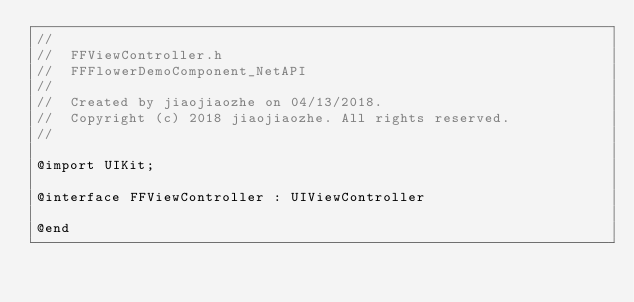<code> <loc_0><loc_0><loc_500><loc_500><_C_>//
//  FFViewController.h
//  FFFlowerDemoComponent_NetAPI
//
//  Created by jiaojiaozhe on 04/13/2018.
//  Copyright (c) 2018 jiaojiaozhe. All rights reserved.
//

@import UIKit;

@interface FFViewController : UIViewController

@end
</code> 